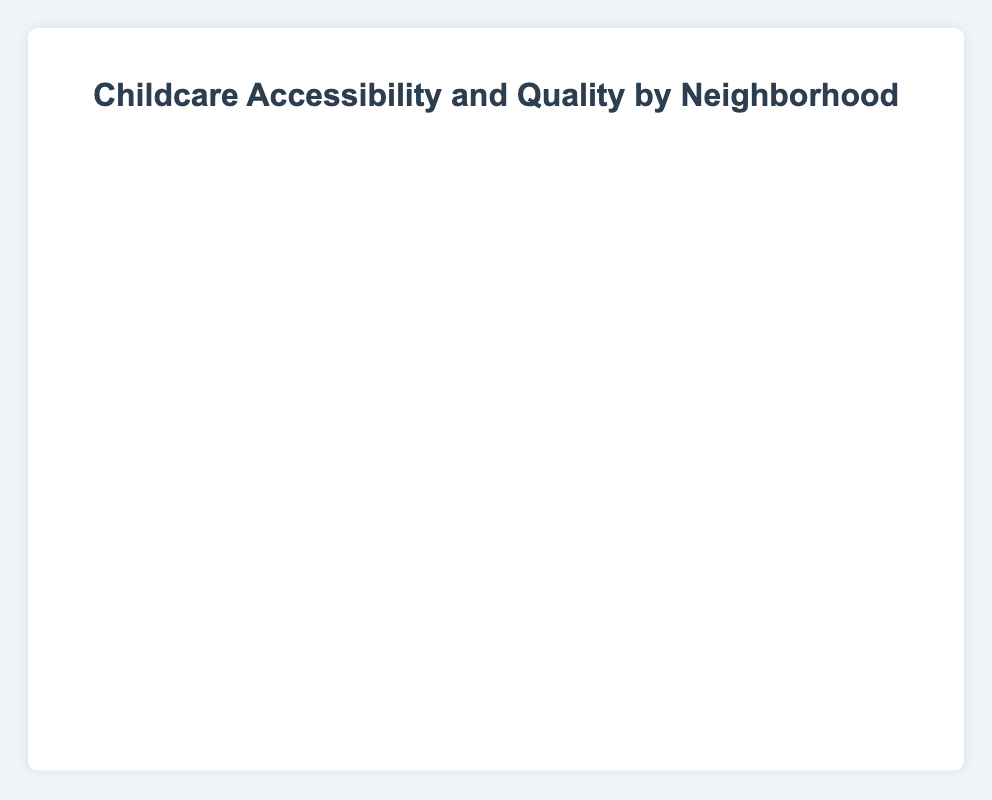How many neighborhoods have a Quality Rating above 4.0? By looking at the y-axis, count all the data points whose y (Quality Rating) is greater than 4.0. For Downtown (4.5), Brooklyn (4.6), Queens (4.2), and Staten Island (4.1), it totals 4 neighborhoods.
Answer: 4 Which neighborhood has the highest Accessibility Score? Compare the x-values of all data points. Brooklyn has the highest x-value of 90.
Answer: Brooklyn What is the total number of childcare centers in neighborhoods with an Accessibility Score below 70? Identify the neighborhoods with an Accessibility Score below 70 (Uptown, Harlem, Bronx) and sum their 'Number of Childcare Centers' values: 10 (Uptown) + 8 (Harlem) + 7 (Bronx) = 25.
Answer: 25 Is there a neighborhood with a high Accessibility Score but a low Quality Rating? Look for neighborhoods with a high x-value but low y-value. Staten Island has an Accessibility Score of 80 and a Quality Rating of 4.1, which is not very low. Harlem has a Quality Rating of 3.5, which is low, but its Accessibility Score is only 60. None have a high Accessibility Score and a low Quality Rating simultaneously.
Answer: No Which neighborhood has the largest number of childcare centers? Compare the size of the data points (radius, r-value). Brooklyn, with 25 childcare centers, has the largest bubble.
Answer: Brooklyn Compare the Accessibility Score and Quality Rating of Downtown and Midtown. Which neighborhood has better accessibility and quality? Downtown has an Accessibility Score of 85 and Quality Rating of 4.5, while Midtown has an Accessibility Score of 75 and Quality Rating of 4.0. Downtown scores higher in both metrics.
Answer: Downtown Calculate the average Accessibility Score of all neighborhoods. Sum the Accessibility Scores and divide by the number of neighborhoods: (85 + 75 + 65 + 90 + 70 + 60 + 55 + 80) / 8 = 580 / 8 = 72.5.
Answer: 72.5 Which neighborhood has the lowest Quality Rating and how many childcare centers does it have? Compare the y-values of all data points. Bronx has the lowest Quality Rating (3.2) with 7 childcare centers.
Answer: Bronx, 7 